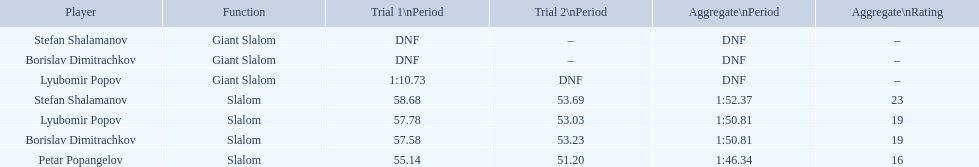Which event is the giant slalom? Giant Slalom, Giant Slalom, Giant Slalom. Which one is lyubomir popov? Lyubomir Popov. Would you mind parsing the complete table? {'header': ['Player', 'Function', 'Trial 1\\nPeriod', 'Trial 2\\nPeriod', 'Aggregate\\nPeriod', 'Aggregate\\nRating'], 'rows': [['Stefan Shalamanov', 'Giant Slalom', 'DNF', '–', 'DNF', '–'], ['Borislav Dimitrachkov', 'Giant Slalom', 'DNF', '–', 'DNF', '–'], ['Lyubomir Popov', 'Giant Slalom', '1:10.73', 'DNF', 'DNF', '–'], ['Stefan Shalamanov', 'Slalom', '58.68', '53.69', '1:52.37', '23'], ['Lyubomir Popov', 'Slalom', '57.78', '53.03', '1:50.81', '19'], ['Borislav Dimitrachkov', 'Slalom', '57.58', '53.23', '1:50.81', '19'], ['Petar Popangelov', 'Slalom', '55.14', '51.20', '1:46.34', '16']]} What is race 1 tim? 1:10.73. 